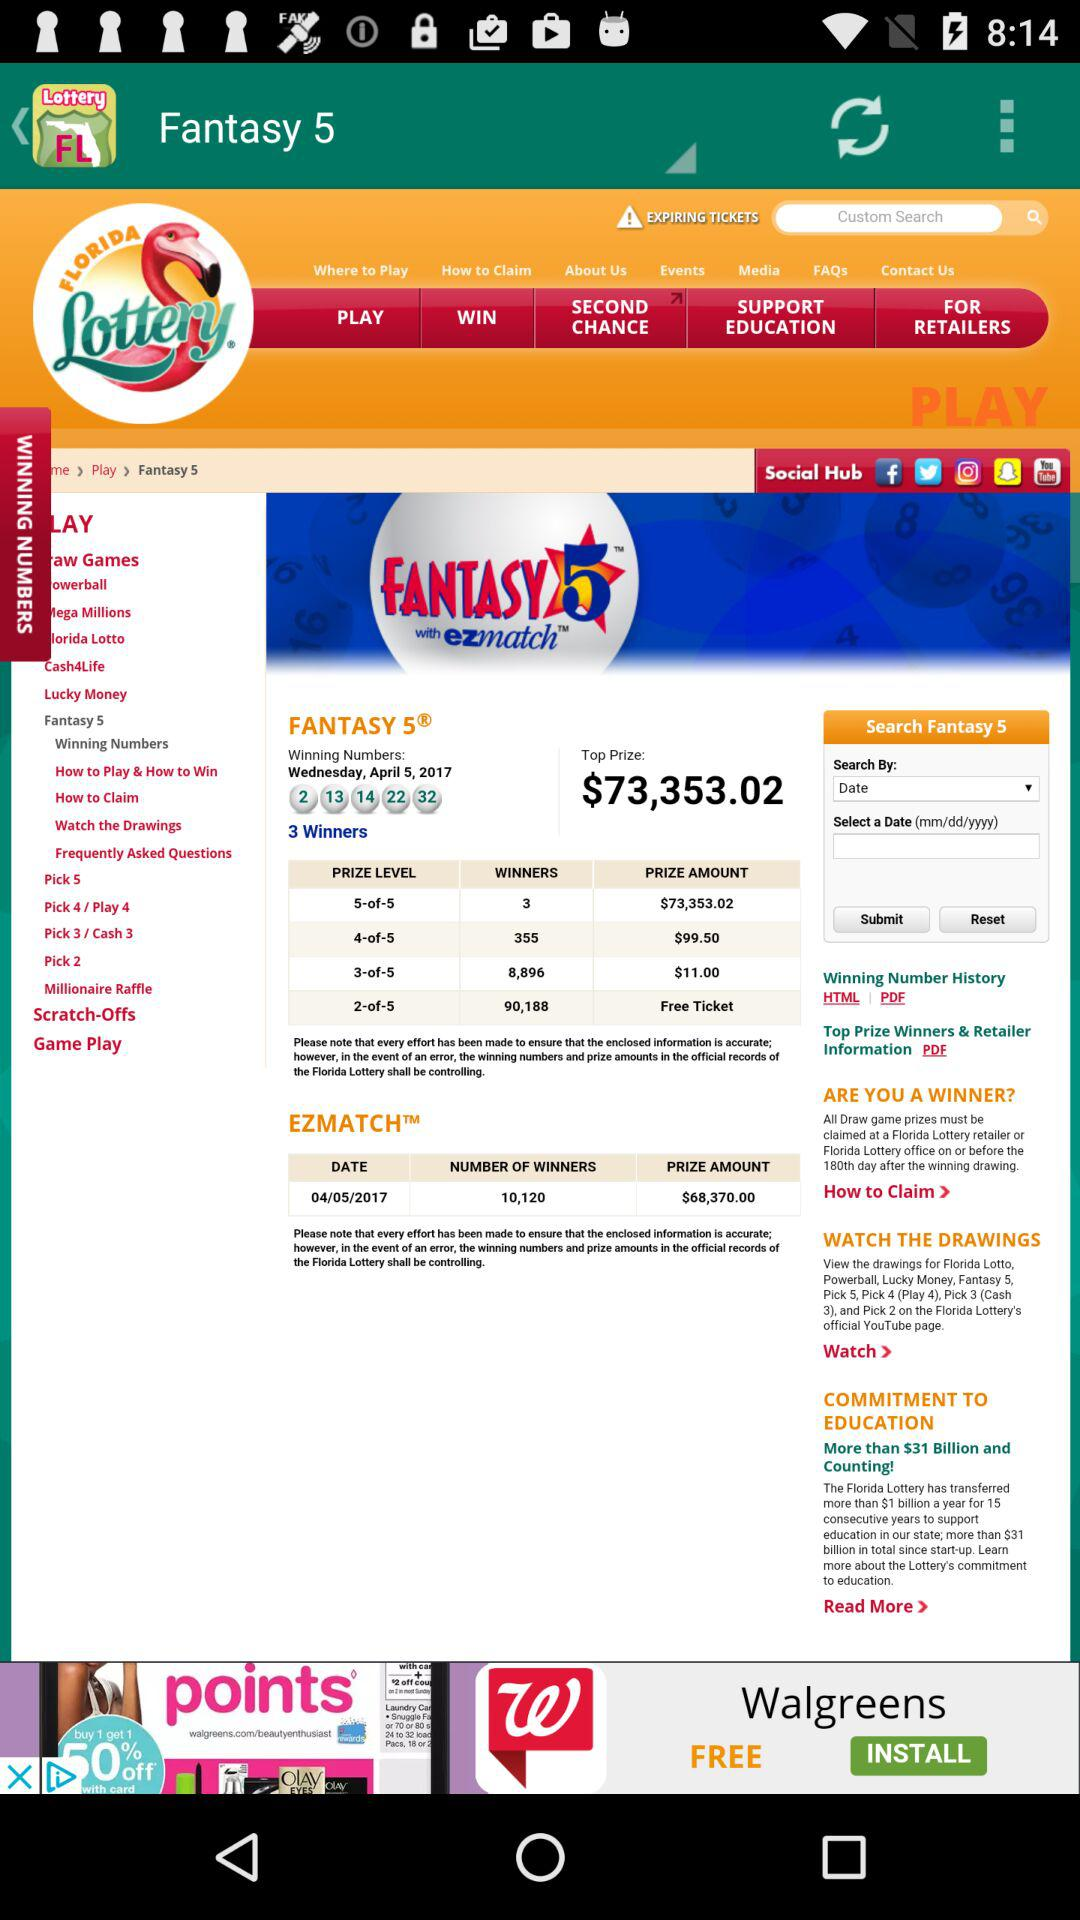What are the winning numbers in "Fantasy 5"? The winning numbers in "Fantasy 5" are 2, 13, 14, 22 and 32. 